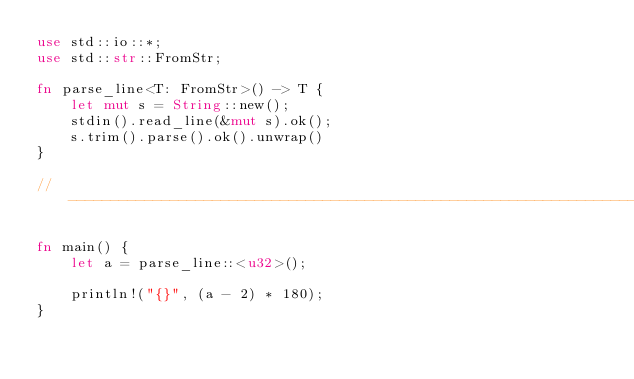Convert code to text. <code><loc_0><loc_0><loc_500><loc_500><_Rust_>use std::io::*;
use std::str::FromStr;

fn parse_line<T: FromStr>() -> T {
    let mut s = String::new();
    stdin().read_line(&mut s).ok();
    s.trim().parse().ok().unwrap()
}

// ------------------------------------------------------------------------

fn main() {
    let a = parse_line::<u32>();

    println!("{}", (a - 2) * 180);
}
</code> 